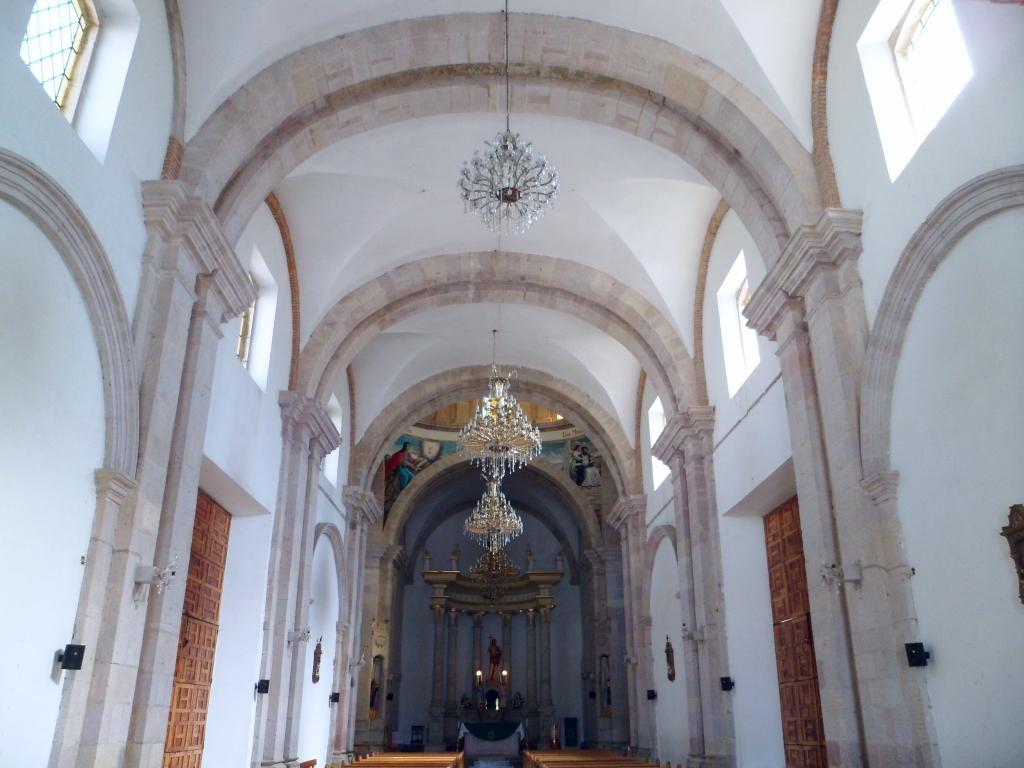In one or two sentences, can you explain what this image depicts? In this image there are chandeliers hanging and there are doors and there are walls and in the background there is a statue and on the top there are windows. 